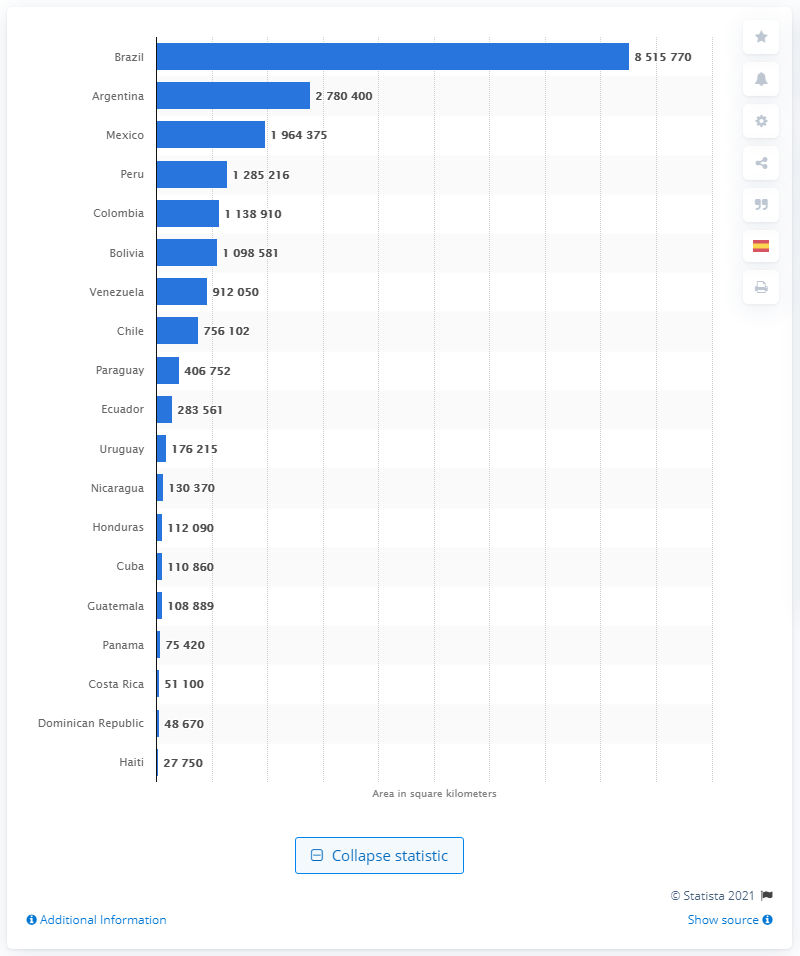Can you describe what this image is showing? The image displays a bar graph ranking countries in Latin America by the size of their total area in square kilometers. Brazil tops the chart by a substantial margin. 